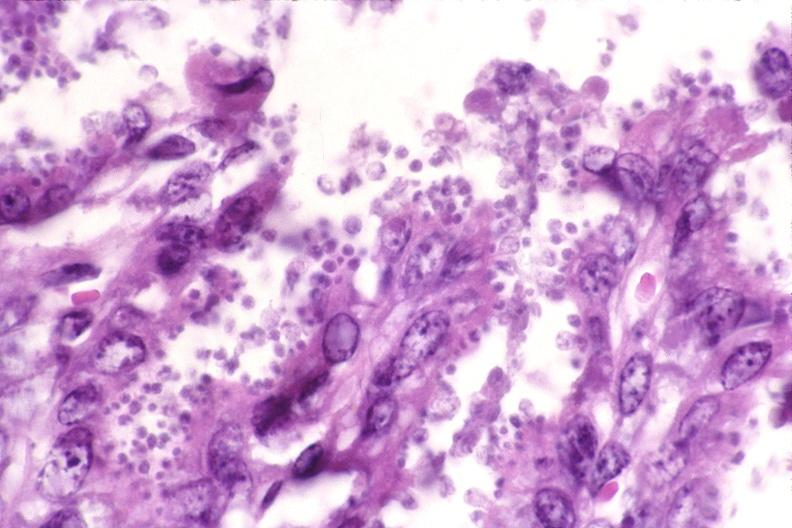does this image show colon, cryptosporidia?
Answer the question using a single word or phrase. Yes 